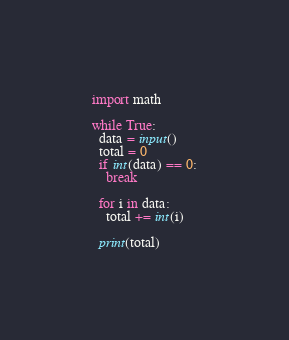Convert code to text. <code><loc_0><loc_0><loc_500><loc_500><_Python_>import math

while True:
  data = input()
  total = 0
  if int(data) == 0:
    break

  for i in data:
    total += int(i)
  
  print(total)
</code> 